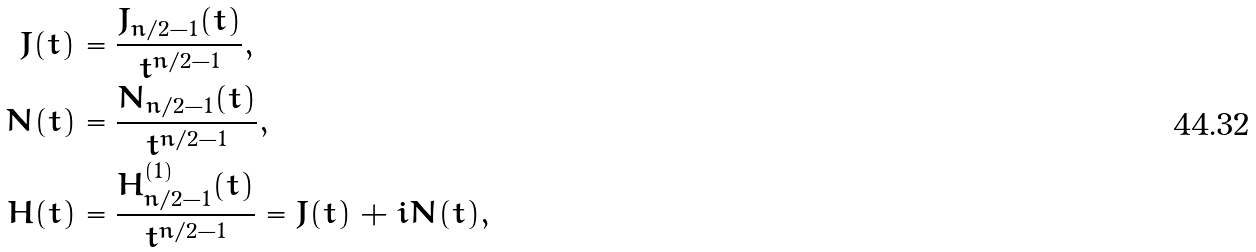Convert formula to latex. <formula><loc_0><loc_0><loc_500><loc_500>J ( t ) & = \frac { J _ { n / 2 - 1 } ( t ) } { t ^ { n / 2 - 1 } } , \\ N ( t ) & = \frac { N _ { n / 2 - 1 } ( t ) } { t ^ { n / 2 - 1 } } , \\ H ( t ) & = \frac { H _ { n / 2 - 1 } ^ { ( 1 ) } ( t ) } { t ^ { n / 2 - 1 } } = J ( t ) + i N ( t ) ,</formula> 